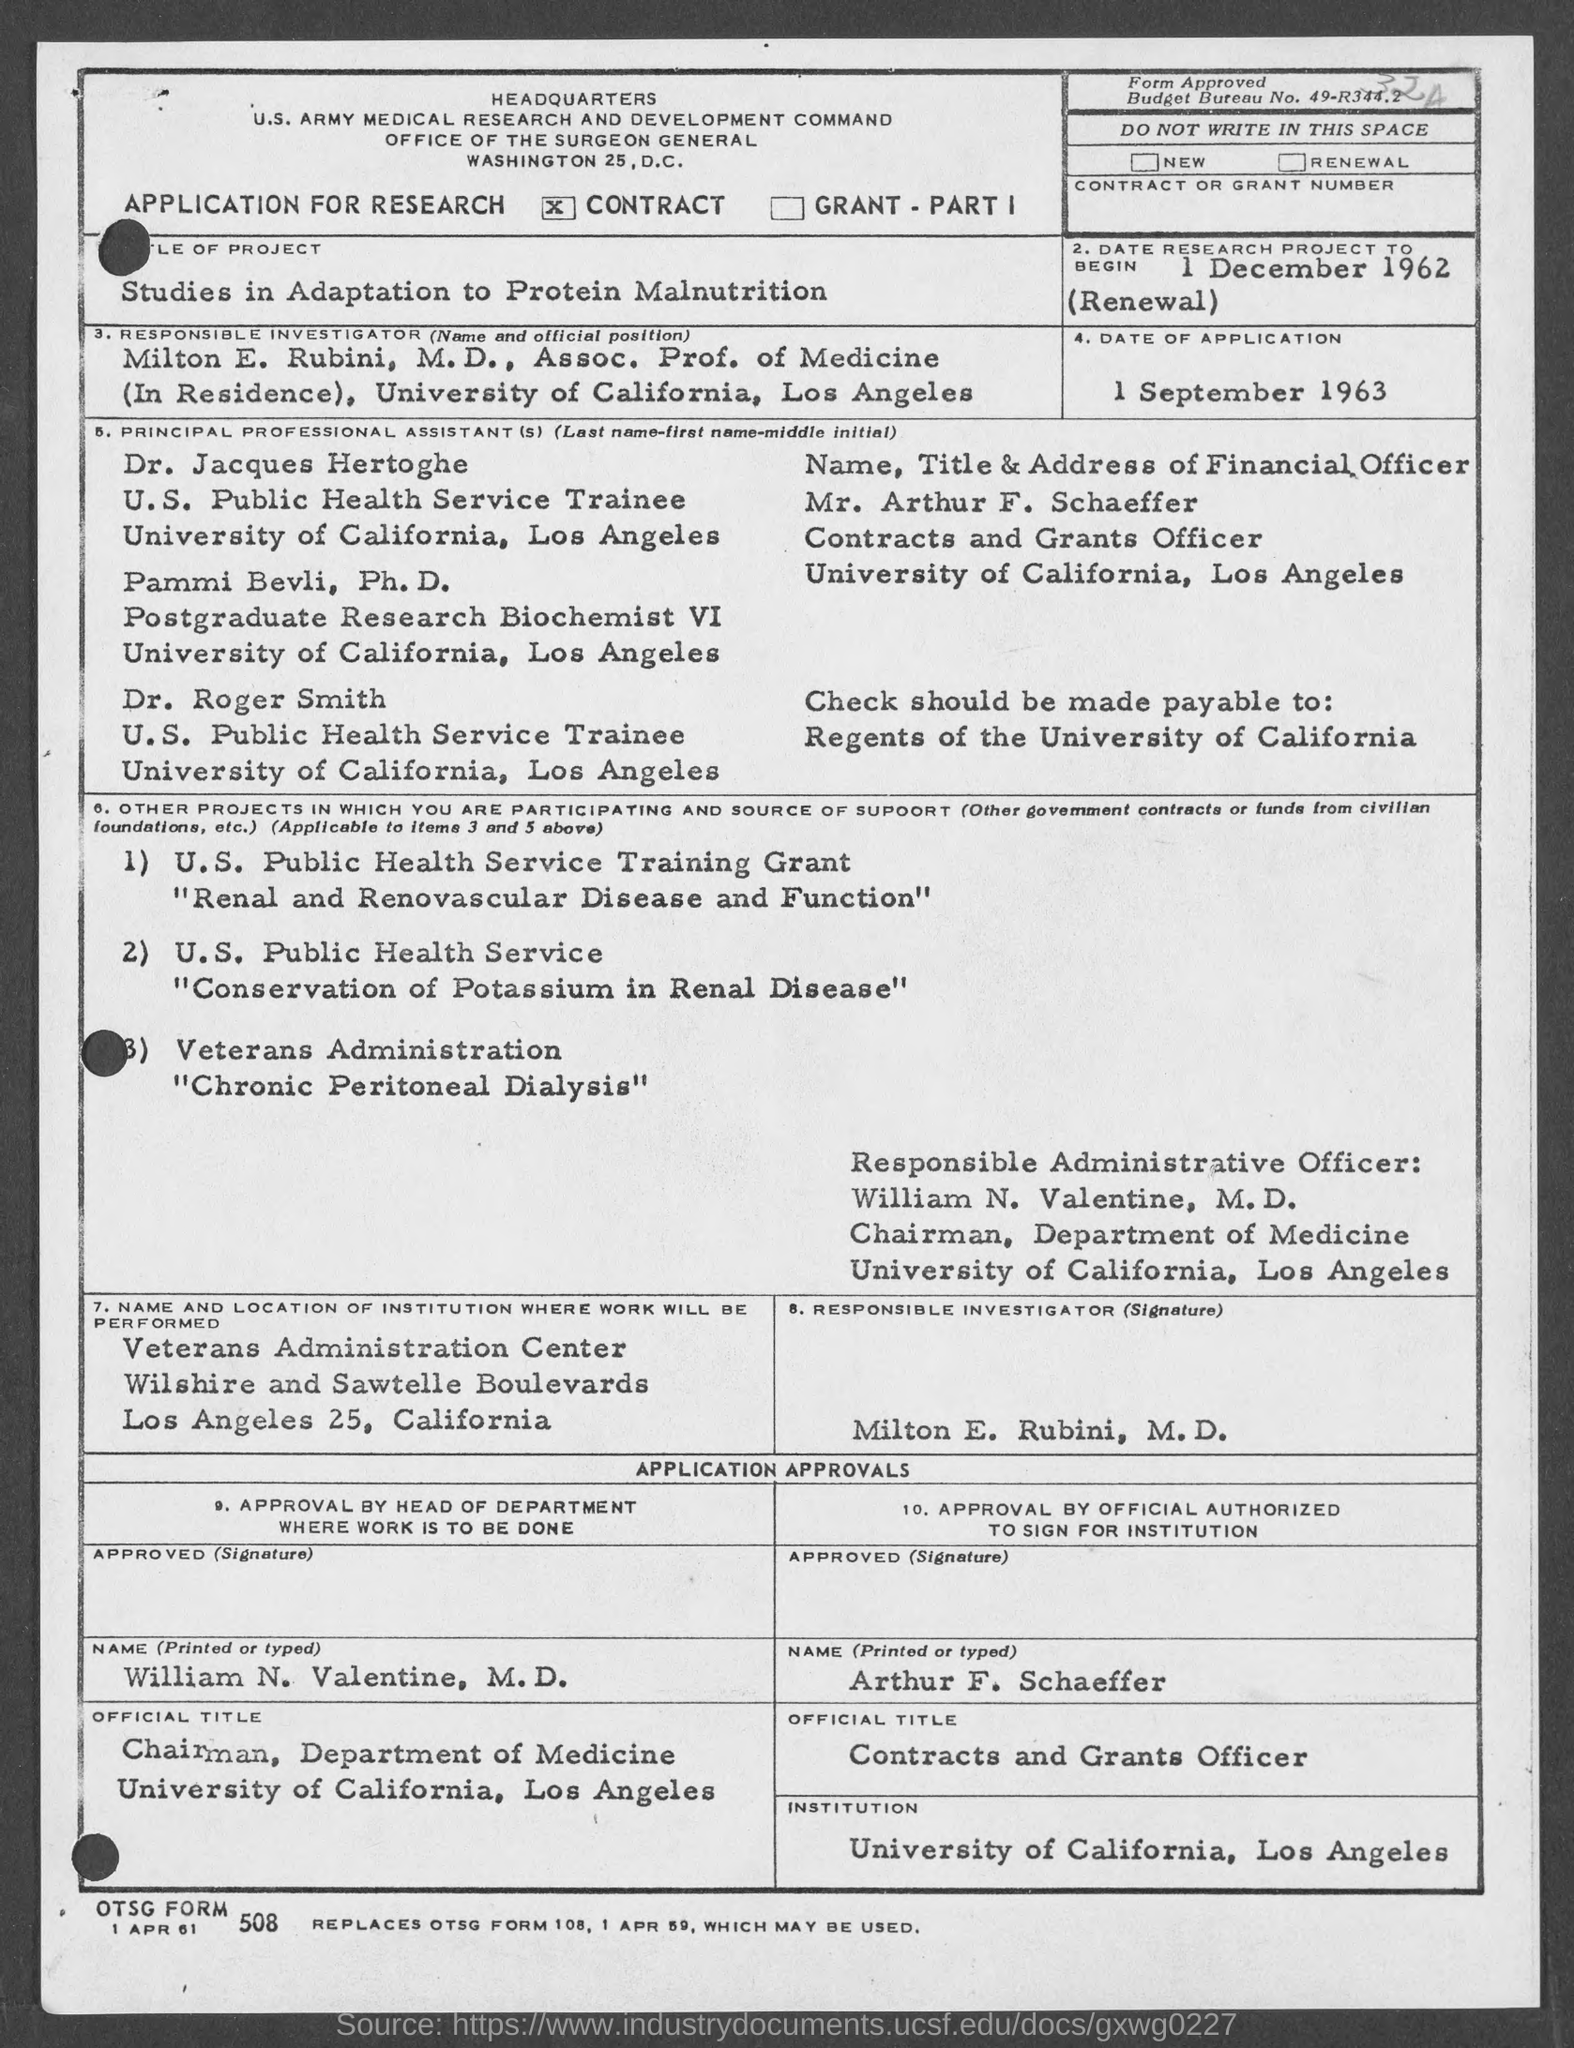What is the Budget Bureau No.?
Offer a terse response. 49-R344.2. What is the form about?
Ensure brevity in your answer.  APPLICATION FOR RESEARCH. What type of application is this?
Give a very brief answer. CONTRACT. What is the title of the project?
Give a very brief answer. Studies in adaptation to protein malnutrition. Who is the responsible investigator?
Provide a short and direct response. Milton E. Rubini. What is Milton's official position?
Give a very brief answer. Assoc. Prof. of Medicine (In Residence). What is the date of application?
Keep it short and to the point. 1 September 1963. Who is the Contracts and Grants Officer?
Provide a succinct answer. Mr. Arthur F. Schaeffer. To whom should checks be payable?
Your answer should be very brief. Regents of the University of California. Which project is from Veterans Administration?
Ensure brevity in your answer.  "Chronic Peritoneal Dialysis". 